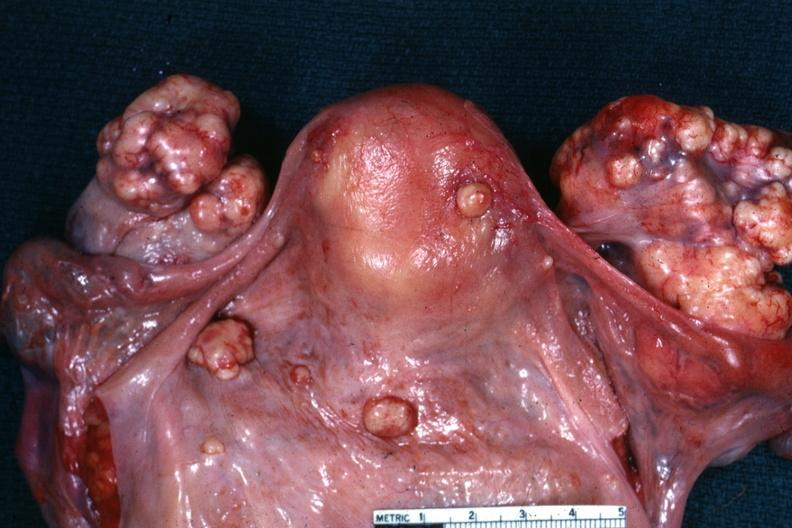what does this image show?
Answer the question using a single word or phrase. View of uterus tubes and ovaries showing large nodular metastatic tumor masses on ovaries 